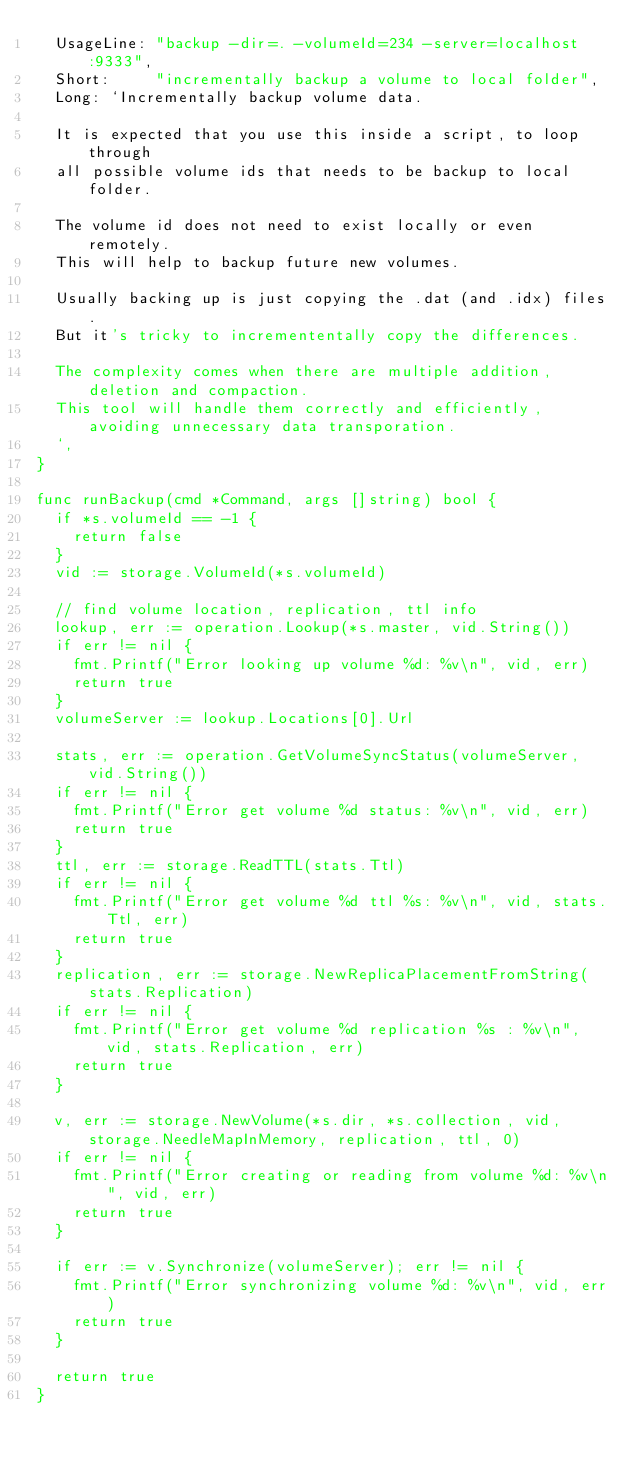<code> <loc_0><loc_0><loc_500><loc_500><_Go_>	UsageLine: "backup -dir=. -volumeId=234 -server=localhost:9333",
	Short:     "incrementally backup a volume to local folder",
	Long: `Incrementally backup volume data.
	
	It is expected that you use this inside a script, to loop through
	all possible volume ids that needs to be backup to local folder.
	
	The volume id does not need to exist locally or even remotely.
	This will help to backup future new volumes.
	
	Usually backing up is just copying the .dat (and .idx) files.
	But it's tricky to incremententally copy the differences.
	
	The complexity comes when there are multiple addition, deletion and compaction.
	This tool will handle them correctly and efficiently, avoiding unnecessary data transporation.
  `,
}

func runBackup(cmd *Command, args []string) bool {
	if *s.volumeId == -1 {
		return false
	}
	vid := storage.VolumeId(*s.volumeId)

	// find volume location, replication, ttl info
	lookup, err := operation.Lookup(*s.master, vid.String())
	if err != nil {
		fmt.Printf("Error looking up volume %d: %v\n", vid, err)
		return true
	}
	volumeServer := lookup.Locations[0].Url

	stats, err := operation.GetVolumeSyncStatus(volumeServer, vid.String())
	if err != nil {
		fmt.Printf("Error get volume %d status: %v\n", vid, err)
		return true
	}
	ttl, err := storage.ReadTTL(stats.Ttl)
	if err != nil {
		fmt.Printf("Error get volume %d ttl %s: %v\n", vid, stats.Ttl, err)
		return true
	}
	replication, err := storage.NewReplicaPlacementFromString(stats.Replication)
	if err != nil {
		fmt.Printf("Error get volume %d replication %s : %v\n", vid, stats.Replication, err)
		return true
	}

	v, err := storage.NewVolume(*s.dir, *s.collection, vid, storage.NeedleMapInMemory, replication, ttl, 0)
	if err != nil {
		fmt.Printf("Error creating or reading from volume %d: %v\n", vid, err)
		return true
	}

	if err := v.Synchronize(volumeServer); err != nil {
		fmt.Printf("Error synchronizing volume %d: %v\n", vid, err)
		return true
	}

	return true
}
</code> 